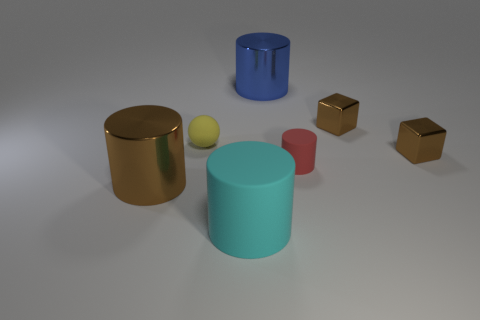Subtract 4 cylinders. How many cylinders are left? 0 Add 2 small brown shiny things. How many objects exist? 9 Subtract all large brown cylinders. How many cylinders are left? 3 Add 1 tiny brown cubes. How many tiny brown cubes are left? 3 Add 4 brown shiny objects. How many brown shiny objects exist? 7 Subtract all brown cylinders. How many cylinders are left? 3 Subtract 0 purple spheres. How many objects are left? 7 Subtract all cylinders. How many objects are left? 3 Subtract all red blocks. Subtract all green balls. How many blocks are left? 2 Subtract all blue balls. How many gray blocks are left? 0 